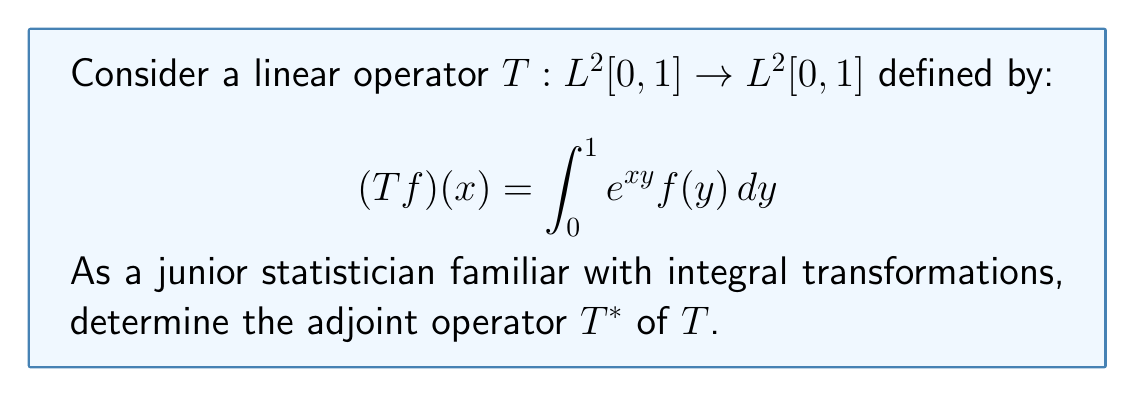Solve this math problem. To find the adjoint operator $T^*$, we need to use the definition of the adjoint in a Hilbert space (which $L^2[0,1]$ is). For any $f, g \in L^2[0,1]$, the adjoint $T^*$ satisfies:

$$\langle Tf, g \rangle = \langle f, T^*g \rangle$$

Let's follow these steps:

1) First, let's expand the left side of the equation:

   $$\langle Tf, g \rangle = \int_0^1 (Tf)(x) \overline{g(x)} dx$$

2) Substitute the definition of $T$:

   $$\langle Tf, g \rangle = \int_0^1 \left(\int_0^1 e^{xy} f(y) dy\right) \overline{g(x)} dx$$

3) Now, we can change the order of integration (Fubini's theorem):

   $$\langle Tf, g \rangle = \int_0^1 \int_0^1 e^{xy} f(y) \overline{g(x)} dx dy$$

4) Rearrange the integrals:

   $$\langle Tf, g \rangle = \int_0^1 f(y) \left(\int_0^1 e^{xy} \overline{g(x)} dx\right) dy$$

5) The expression in parentheses should define $(T^*g)(y)$. Therefore:

   $$(T^*g)(y) = \int_0^1 e^{xy} \overline{g(x)} dx$$

6) To get the final form, we need to conjugate both sides (since we used $\overline{g(x)}$ in our derivation):

   $$(T^*g)(y) = \overline{\int_0^1 e^{xy} g(x) dx}$$

This is the adjoint operator $T^*$ we were looking for.
Answer: The adjoint operator $T^*: L^2[0,1] \to L^2[0,1]$ is given by:

$$(T^*g)(y) = \overline{\int_0^1 e^{xy} g(x) dx}$$

for $g \in L^2[0,1]$ and $y \in [0,1]$. 